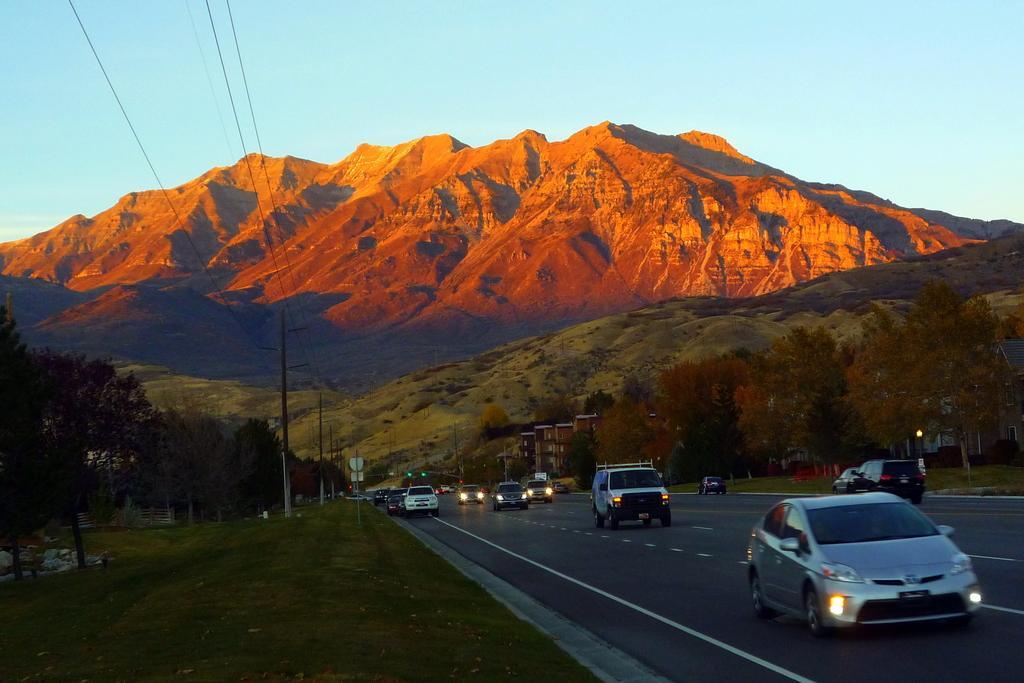How would you summarize this image in a sentence or two? In this picture we can see vehicles on the road, here we can see buildings, trees, traffic signals, electric poles and some objects and in the background we can see mountains, sky. 